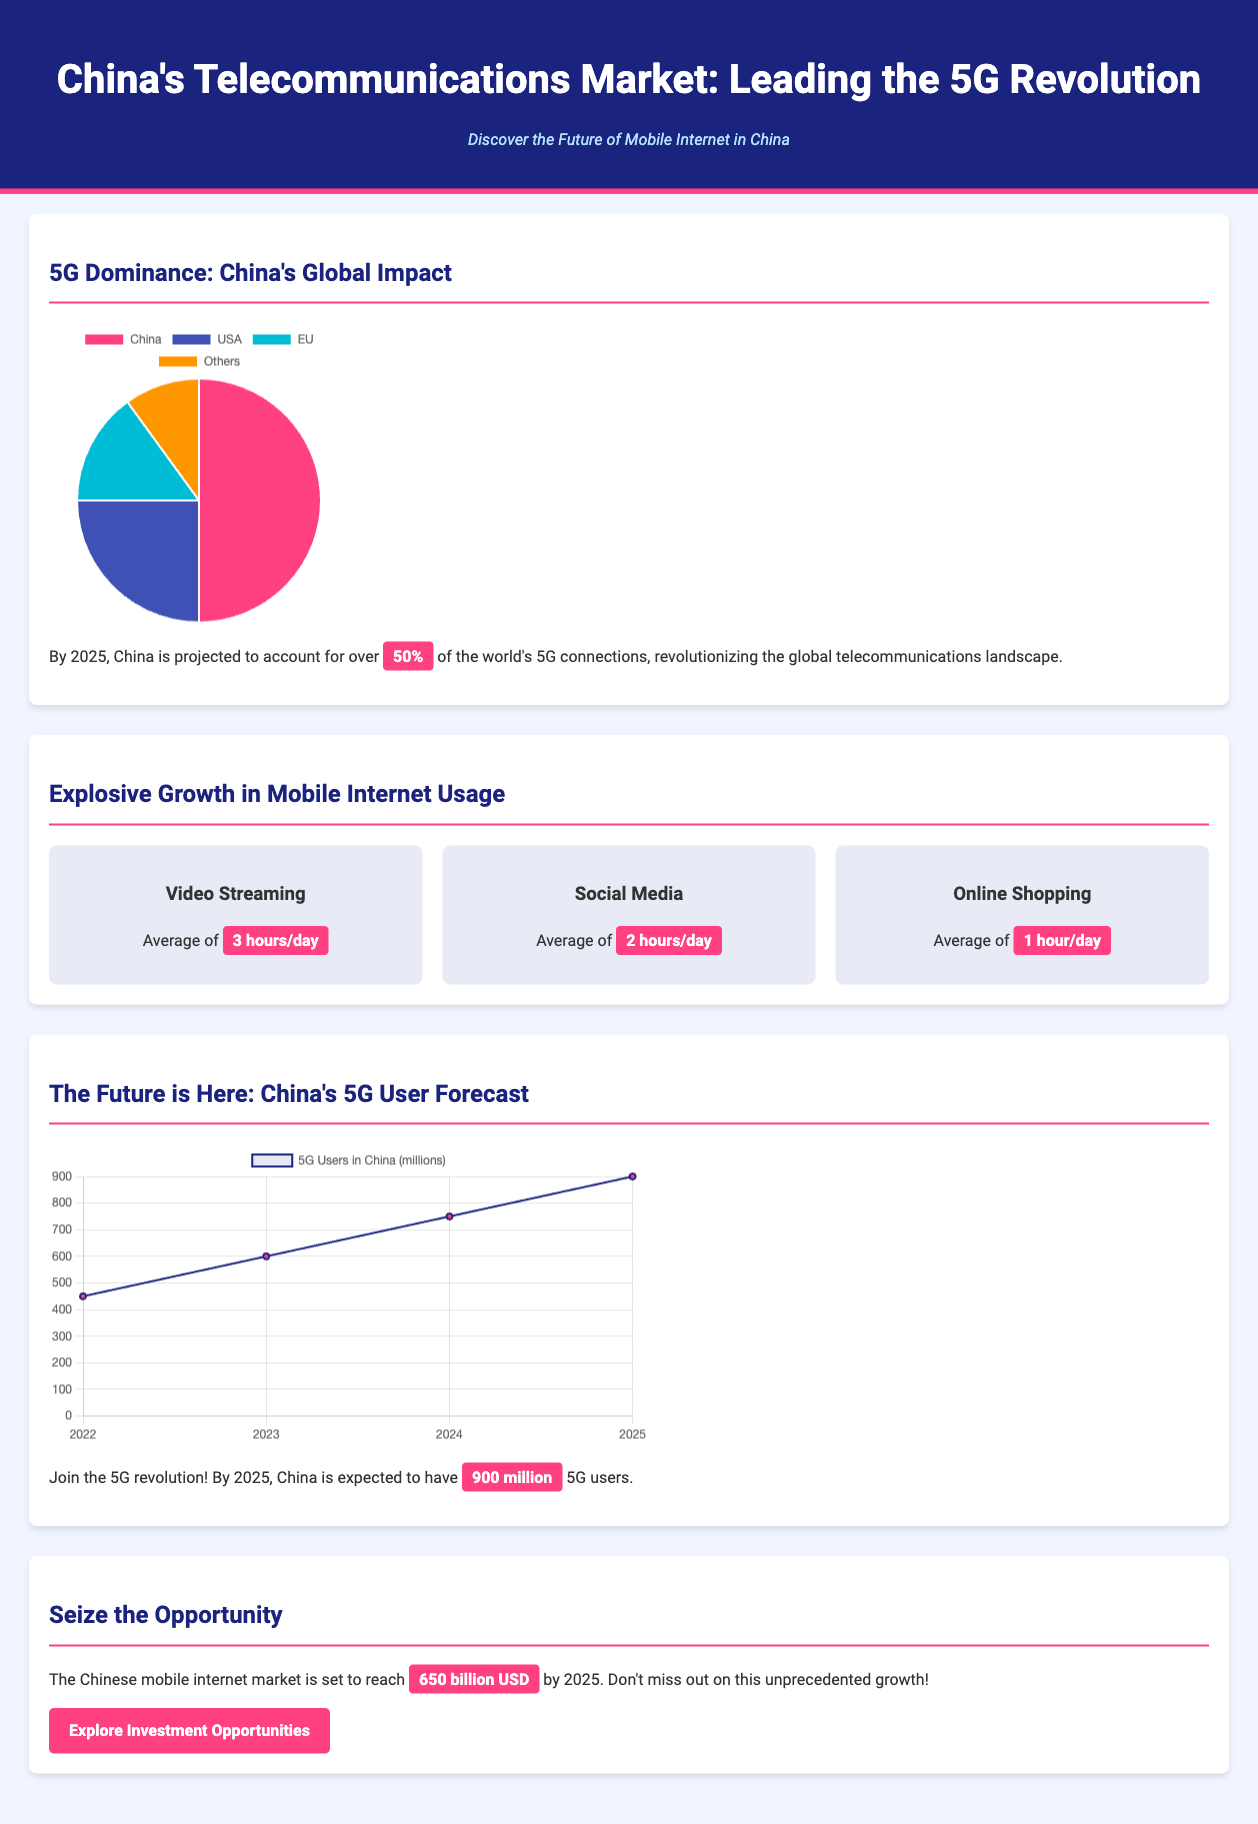What percentage of the world's 5G connections will China account for by 2025? The document states that by 2025, China is projected to account for over 50% of the world's 5G connections.
Answer: 50% What is the average time spent on video streaming daily? The advertisement mentions that the average time spent on video streaming is 3 hours per day.
Answer: 3 hours How many 5G users is China expected to have by 2025? The document indicates that by 2025, China is expected to have 900 million 5G users.
Answer: 900 million What is the projected market size of the Chinese mobile internet market by 2025? The projected market size of the Chinese mobile internet market by 2025 is stated as 650 billion USD.
Answer: 650 billion USD Which country has the highest share in the global 5G market according to the pie chart? The pie chart illustrates that China has the highest share in the global 5G market.
Answer: China What is the primary color of the highlight used in the document? The highlight color used in the document is a shade of pink, referred to as 'ff4081'.
Answer: pink How does the number of 5G users in China progress from 2022 to 2025? The user forecast chart shows a clear upward trend in 5G users, from 450 million in 2022 to 900 million in 2025.
Answer: upward trend What call to action is presented at the end of the advertisement? The document concludes with a call to action encouraging readers to explore investment opportunities.
Answer: Explore Investment Opportunities 